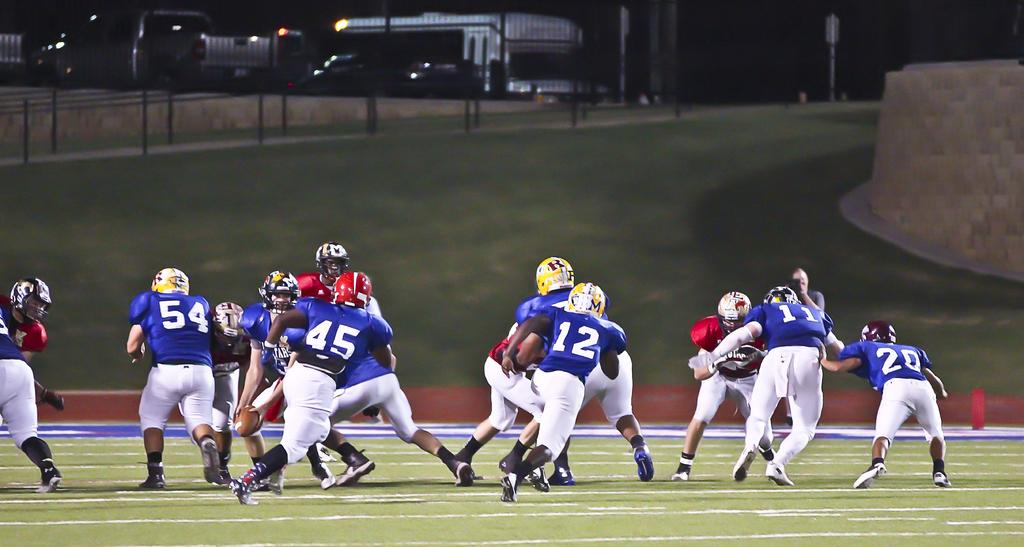What are the people in the image doing? There are many persons playing on the ground in the image. What can be seen in the background of the image? There is fencing, a building, and a wall in the background of the image. What type of oatmeal is the grandmother eating in the image? There is no grandmother or oatmeal present in the image. What color is the vest worn by the person playing in the image? There is no mention of a vest in the image, as the focus is on the people playing on the ground and the background elements. 